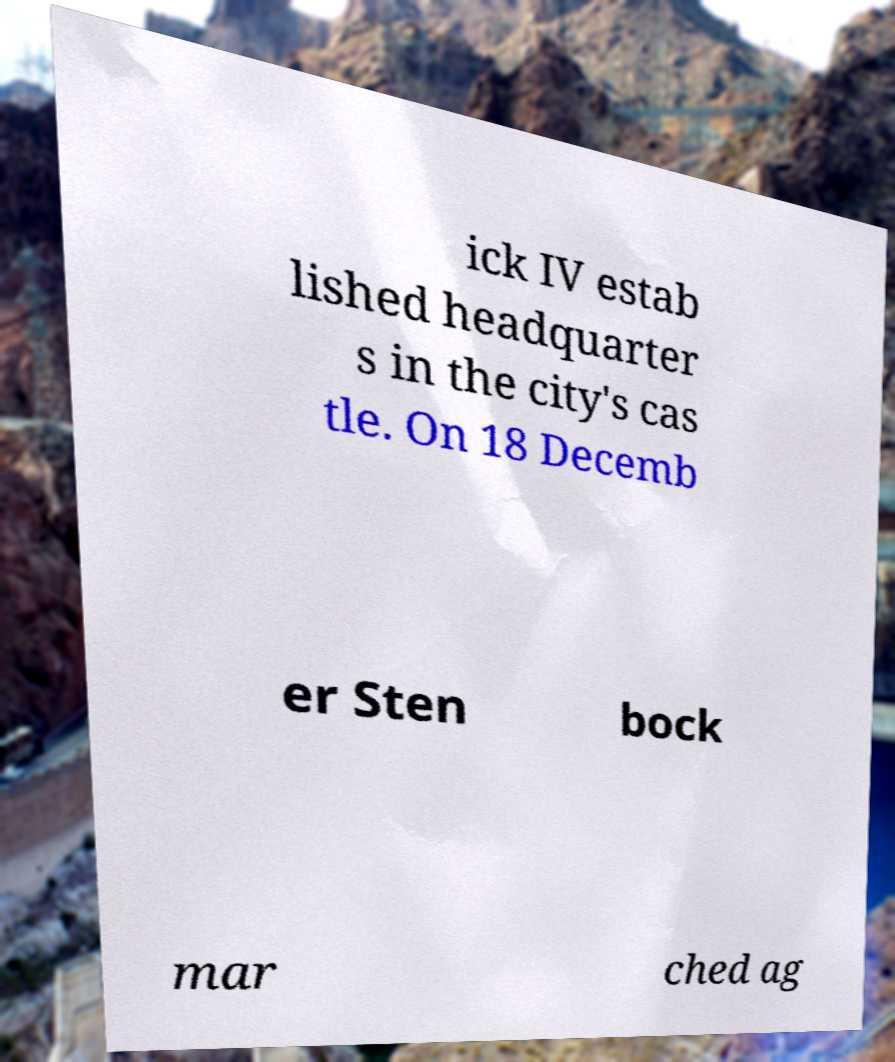Please identify and transcribe the text found in this image. ick IV estab lished headquarter s in the city's cas tle. On 18 Decemb er Sten bock mar ched ag 